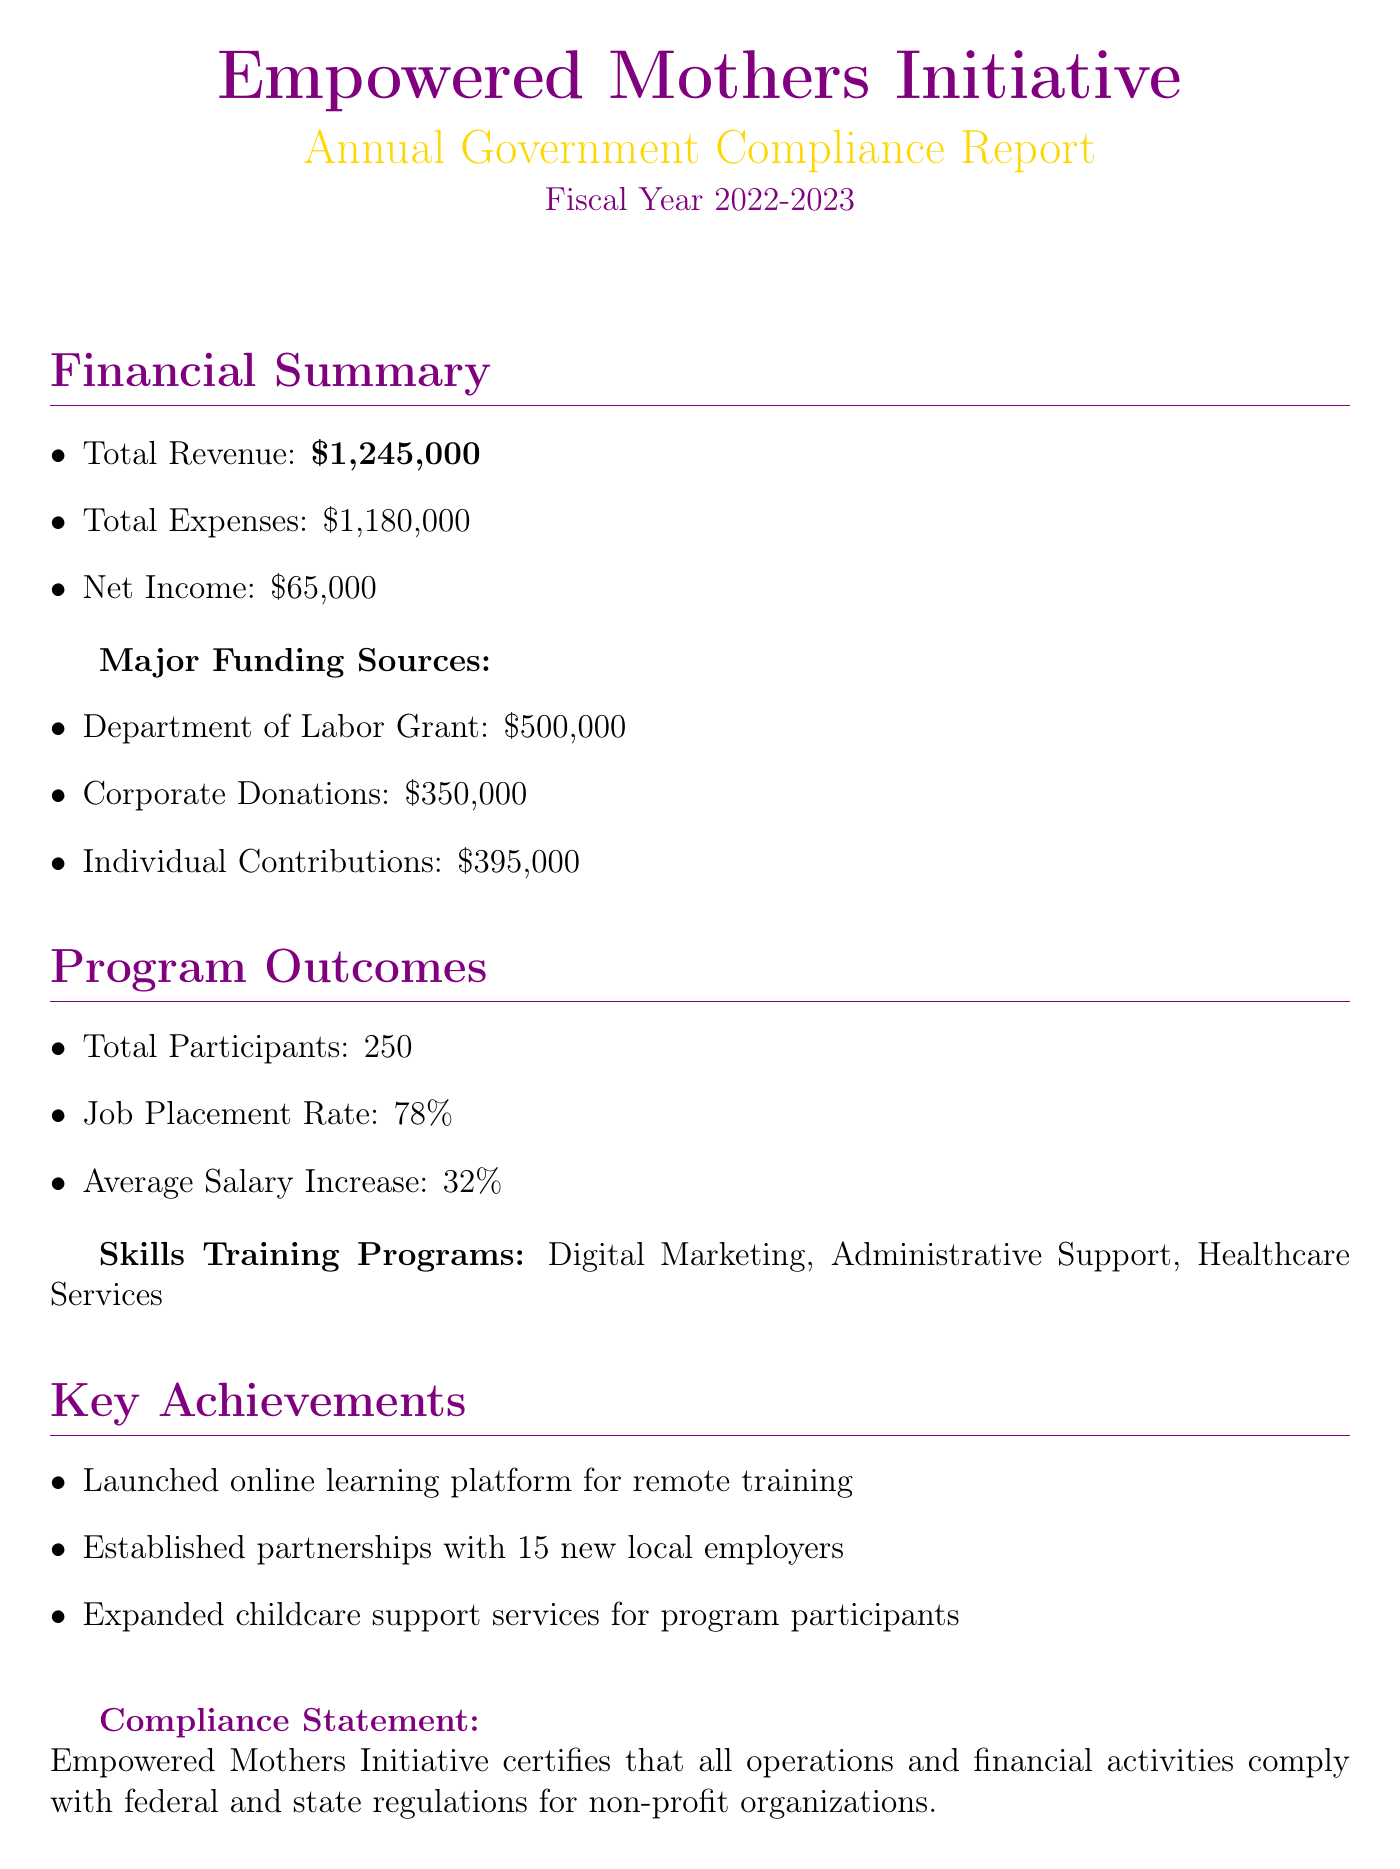What is the total revenue? The total revenue is stated in the financial summary as $1,245,000.
Answer: $1,245,000 What is the total number of participants? The total number of participants is mentioned under program outcomes as 250.
Answer: 250 What was the net income of the organization? The net income is detailed in the financial summary as $65,000.
Answer: $65,000 What is the job placement rate? The job placement rate is specified in the program outcomes as 78%.
Answer: 78% How much funding did the Department of Labor Grant provide? The financial summary lists the Department of Labor Grant funding as $500,000.
Answer: $500,000 What skills training programs are offered? The skills training programs are listed as Digital Marketing, Administrative Support, and Healthcare Services.
Answer: Digital Marketing, Administrative Support, Healthcare Services How many new local employer partnerships were established? The key achievements section states that 15 new local employers were partnered with.
Answer: 15 Who is the director of the Empowered Mothers Initiative? The contact information specifies Sarah Thompson as the director.
Answer: Sarah Thompson What was the average salary increase for participants? The average salary increase is recorded in the program outcomes as 32%.
Answer: 32% 